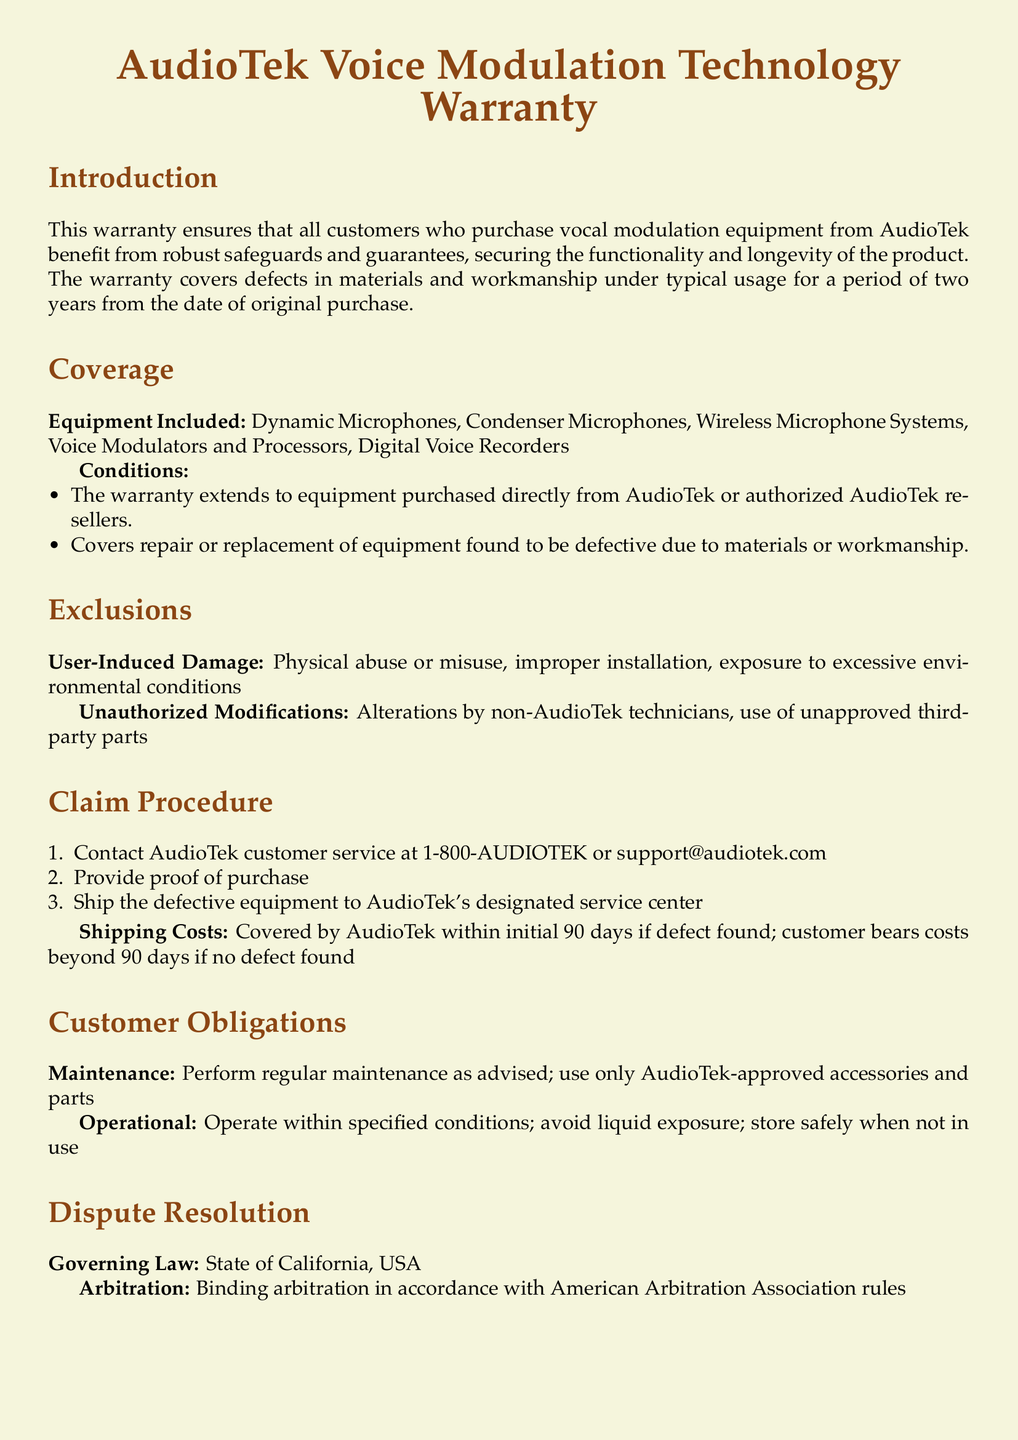What is the warranty period for the vocal modulation equipment? The warranty period is specified as two years from the date of original purchase.
Answer: two years What types of equipment are covered under this warranty? The document lists specific types of equipment that are included in the warranty coverage, such as microphones and voice modulators.
Answer: Dynamic Microphones, Condenser Microphones, Wireless Microphone Systems, Voice Modulators and Processors, Digital Voice Recorders What should you do if you need to make a warranty claim? The procedure for making a warranty claim is outlined in the document, starting with contacting customer service for assistance.
Answer: Contact AudioTek customer service What are the customer service hours? The document provides the hours when customer service can be reached for assistance with warranty inquiries.
Answer: 9 AM to 5 PM PST, Monday to Friday Who covers the shipping costs within the first 90 days if a defect is found? The document clearly states who is responsible for shipping costs in the event that the defect is found within the specified initial period.
Answer: AudioTek What kind of damages are excluded from the warranty? The document outlines specific conditions under which damages will not be covered, emphasizing user-induced damages.
Answer: User-Induced Damage What is the governing law for this warranty? The document specifies the legal jurisdiction under which the warranty will be governed.
Answer: State of California, USA What must customers perform as part of their obligations? The document indicates that customers are required to conduct certain maintenance as part of their responsibilities under the warranty.
Answer: Regular maintenance What kind of arbitration is specified in the warranty? The document mentions the nature of arbitration that would be used to resolve disputes related to the warranty.
Answer: Binding arbitration 